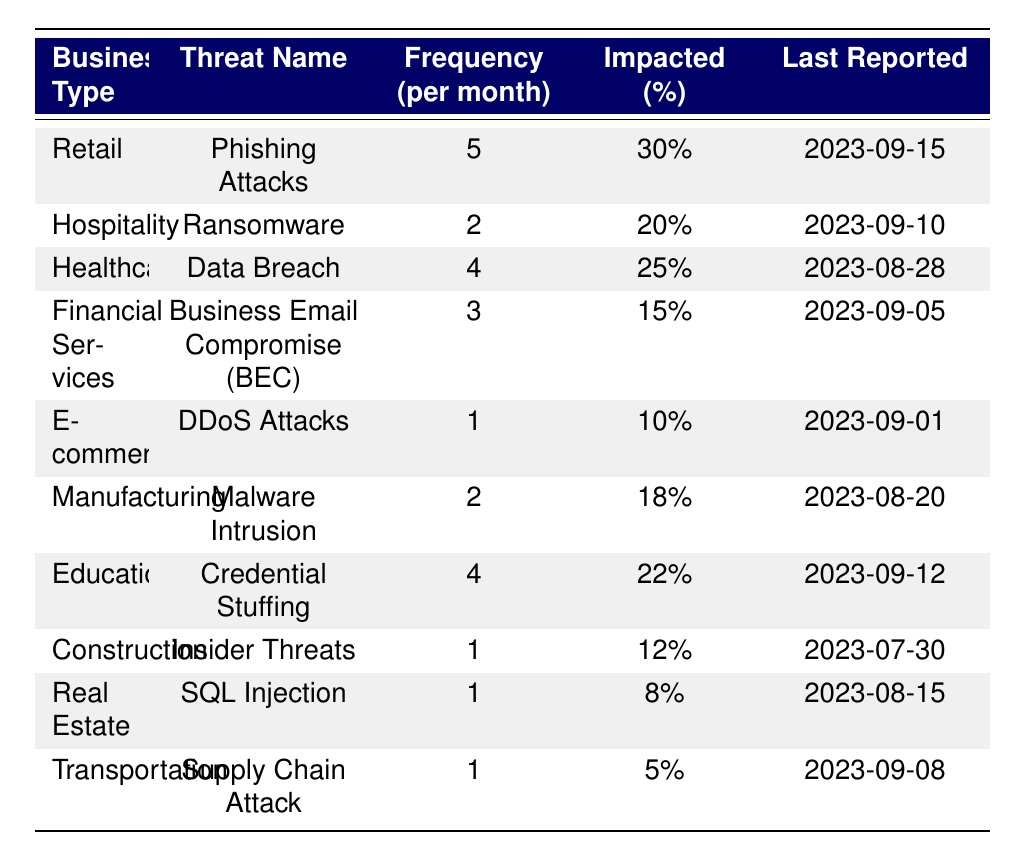What is the frequency of Phishing Attacks faced by Retail businesses? According to the table, the frequency of Phishing Attacks for Retail businesses is 5 per month.
Answer: 5 Which business type has the highest impacted percentage from its most frequent cyber threat? By examining the table, Retail has the highest impacted percentage at 30%.
Answer: Retail How many different cyber threats are reported for the E-commerce sector? The table shows that E-commerce only faces DDoS Attacks, which means there is 1 threat reported.
Answer: 1 What is the average frequency of cyber threats faced by the Healthcare and Education sectors combined? The Healthcare frequency is 4 and the Education frequency is also 4. Adding these gives 4 + 4 = 8. Dividing by 2 (the number of sectors) gives an average of 8/2 = 4.
Answer: 4 Is the last reported date for any of the threats from the Construction business type after September 1, 2023? According to the data, the last reported date for Construction is July 30, 2023, which is not after September 1, 2023.
Answer: No Which threat has the lowest frequency and what is its impacted percentage? The threat with the lowest frequency is the Supply Chain Attack, with a frequency of 1 per month and an impacted percentage of 5%.
Answer: Supply Chain Attack, 5% If we sum the impacted percentages of all threats for Manufacturing and Healthcare, what total do we get? The impacted percentage for Manufacturing is 18% and for Healthcare, it is 25%. Adding them together gives 18 + 25 = 43%.
Answer: 43% What is the total frequency of DDoS Attacks across all business types? The table reveals that only the E-commerce sector faces DDoS Attacks, therefore, the total frequency remains 1.
Answer: 1 Are Ransomware attacks reported to have impacted a higher percentage than Data Breaches? Ransomware has an impacted percentage of 20%, while Data Breaches has 25%. Since 20% is less than 25%, the statement is false.
Answer: No 